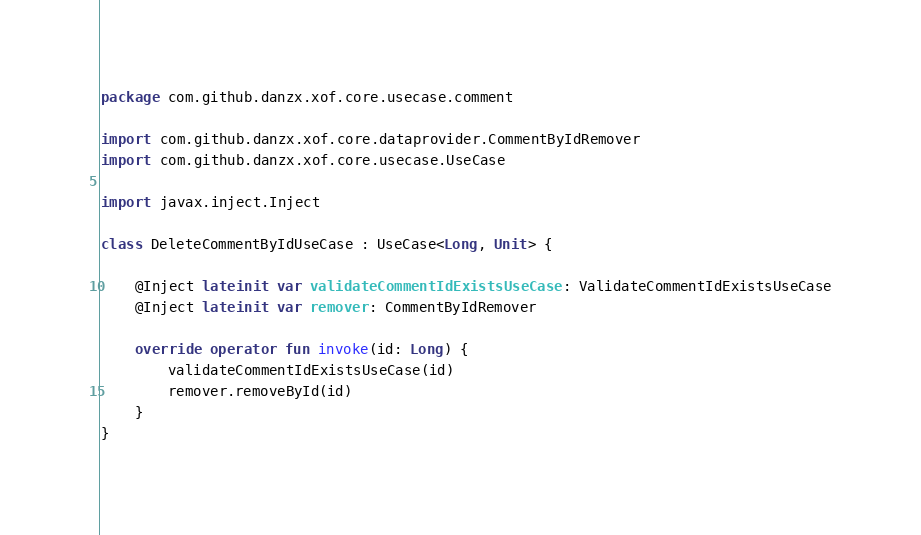Convert code to text. <code><loc_0><loc_0><loc_500><loc_500><_Kotlin_>package com.github.danzx.xof.core.usecase.comment

import com.github.danzx.xof.core.dataprovider.CommentByIdRemover
import com.github.danzx.xof.core.usecase.UseCase

import javax.inject.Inject

class DeleteCommentByIdUseCase : UseCase<Long, Unit> {

    @Inject lateinit var validateCommentIdExistsUseCase: ValidateCommentIdExistsUseCase
    @Inject lateinit var remover: CommentByIdRemover

    override operator fun invoke(id: Long) {
        validateCommentIdExistsUseCase(id)
        remover.removeById(id)
    }
}</code> 